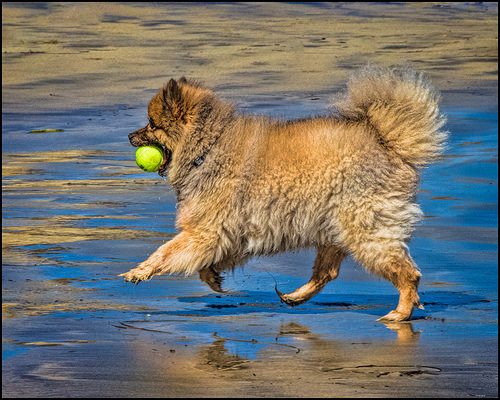<image>
Is the dog behind the ball? Yes. From this viewpoint, the dog is positioned behind the ball, with the ball partially or fully occluding the dog. Is there a ball in the dog? Yes. The ball is contained within or inside the dog, showing a containment relationship. 